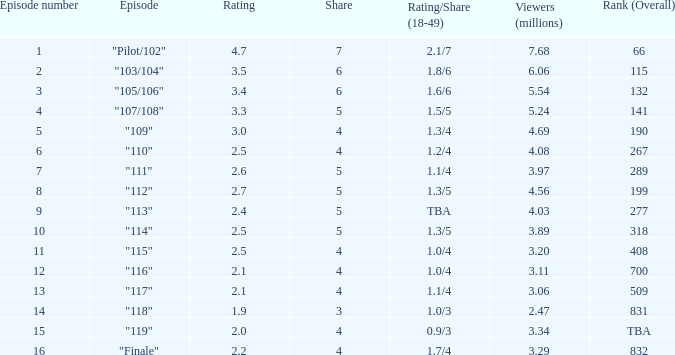WHAT IS THE RATING THAT HAD A SHARE SMALLER THAN 4, AND 2.47 MILLION VIEWERS? 0.0. 